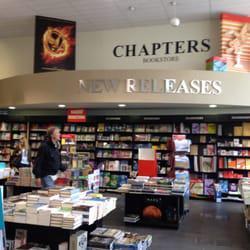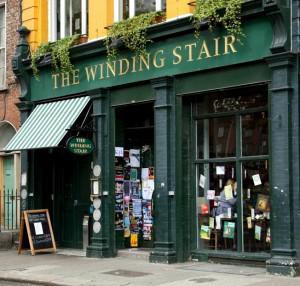The first image is the image on the left, the second image is the image on the right. Analyze the images presented: Is the assertion "Left and right images show the same store exterior, and each storefront has a row of windows with tops that are at least slightly arched." valid? Answer yes or no. No. The first image is the image on the left, the second image is the image on the right. Considering the images on both sides, is "People are walking past the shop in the image on the right." valid? Answer yes or no. No. 